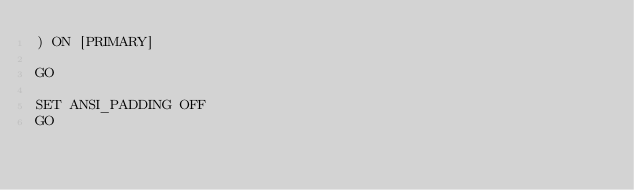<code> <loc_0><loc_0><loc_500><loc_500><_SQL_>) ON [PRIMARY]

GO

SET ANSI_PADDING OFF
GO


</code> 